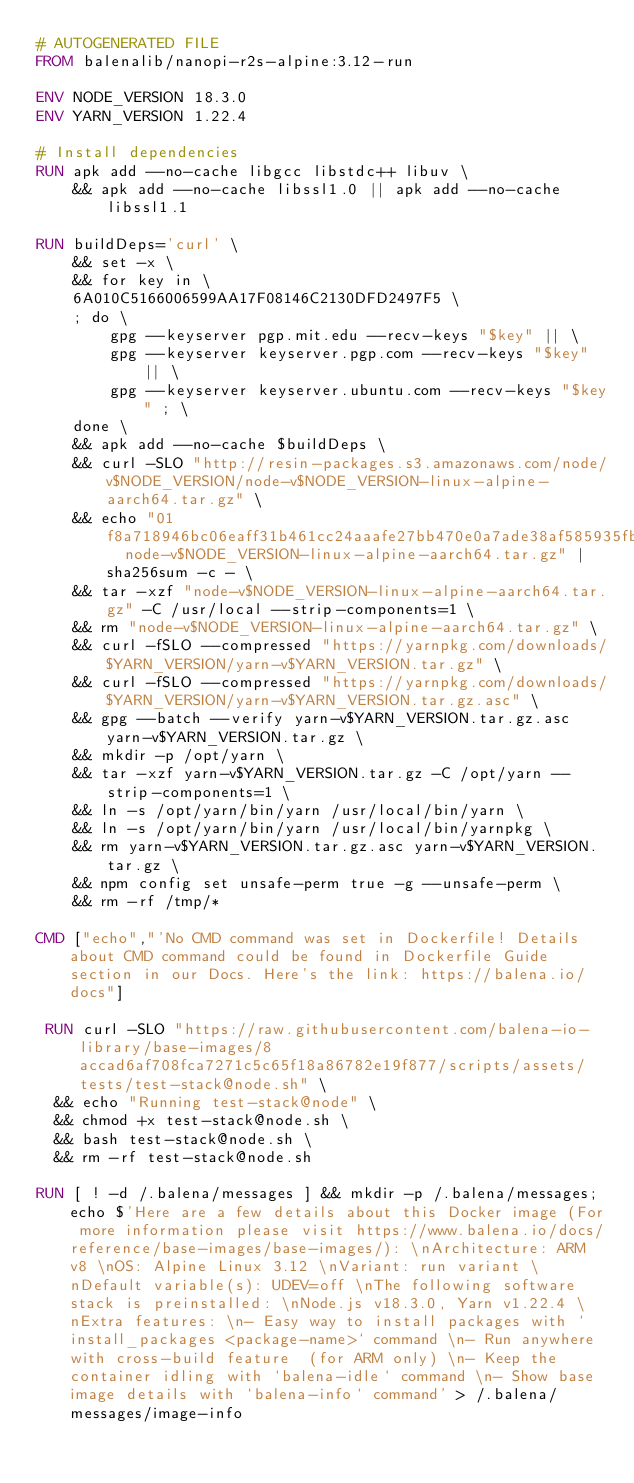<code> <loc_0><loc_0><loc_500><loc_500><_Dockerfile_># AUTOGENERATED FILE
FROM balenalib/nanopi-r2s-alpine:3.12-run

ENV NODE_VERSION 18.3.0
ENV YARN_VERSION 1.22.4

# Install dependencies
RUN apk add --no-cache libgcc libstdc++ libuv \
	&& apk add --no-cache libssl1.0 || apk add --no-cache libssl1.1

RUN buildDeps='curl' \
	&& set -x \
	&& for key in \
	6A010C5166006599AA17F08146C2130DFD2497F5 \
	; do \
		gpg --keyserver pgp.mit.edu --recv-keys "$key" || \
		gpg --keyserver keyserver.pgp.com --recv-keys "$key" || \
		gpg --keyserver keyserver.ubuntu.com --recv-keys "$key" ; \
	done \
	&& apk add --no-cache $buildDeps \
	&& curl -SLO "http://resin-packages.s3.amazonaws.com/node/v$NODE_VERSION/node-v$NODE_VERSION-linux-alpine-aarch64.tar.gz" \
	&& echo "01f8a718946bc06eaff31b461cc24aaafe27bb470e0a7ade38af585935fbd503  node-v$NODE_VERSION-linux-alpine-aarch64.tar.gz" | sha256sum -c - \
	&& tar -xzf "node-v$NODE_VERSION-linux-alpine-aarch64.tar.gz" -C /usr/local --strip-components=1 \
	&& rm "node-v$NODE_VERSION-linux-alpine-aarch64.tar.gz" \
	&& curl -fSLO --compressed "https://yarnpkg.com/downloads/$YARN_VERSION/yarn-v$YARN_VERSION.tar.gz" \
	&& curl -fSLO --compressed "https://yarnpkg.com/downloads/$YARN_VERSION/yarn-v$YARN_VERSION.tar.gz.asc" \
	&& gpg --batch --verify yarn-v$YARN_VERSION.tar.gz.asc yarn-v$YARN_VERSION.tar.gz \
	&& mkdir -p /opt/yarn \
	&& tar -xzf yarn-v$YARN_VERSION.tar.gz -C /opt/yarn --strip-components=1 \
	&& ln -s /opt/yarn/bin/yarn /usr/local/bin/yarn \
	&& ln -s /opt/yarn/bin/yarn /usr/local/bin/yarnpkg \
	&& rm yarn-v$YARN_VERSION.tar.gz.asc yarn-v$YARN_VERSION.tar.gz \
	&& npm config set unsafe-perm true -g --unsafe-perm \
	&& rm -rf /tmp/*

CMD ["echo","'No CMD command was set in Dockerfile! Details about CMD command could be found in Dockerfile Guide section in our Docs. Here's the link: https://balena.io/docs"]

 RUN curl -SLO "https://raw.githubusercontent.com/balena-io-library/base-images/8accad6af708fca7271c5c65f18a86782e19f877/scripts/assets/tests/test-stack@node.sh" \
  && echo "Running test-stack@node" \
  && chmod +x test-stack@node.sh \
  && bash test-stack@node.sh \
  && rm -rf test-stack@node.sh 

RUN [ ! -d /.balena/messages ] && mkdir -p /.balena/messages; echo $'Here are a few details about this Docker image (For more information please visit https://www.balena.io/docs/reference/base-images/base-images/): \nArchitecture: ARM v8 \nOS: Alpine Linux 3.12 \nVariant: run variant \nDefault variable(s): UDEV=off \nThe following software stack is preinstalled: \nNode.js v18.3.0, Yarn v1.22.4 \nExtra features: \n- Easy way to install packages with `install_packages <package-name>` command \n- Run anywhere with cross-build feature  (for ARM only) \n- Keep the container idling with `balena-idle` command \n- Show base image details with `balena-info` command' > /.balena/messages/image-info</code> 